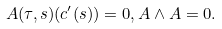Convert formula to latex. <formula><loc_0><loc_0><loc_500><loc_500>A ( \tau , s ) ( c ^ { \prime } ( s ) ) = 0 , A \wedge A = 0 .</formula> 